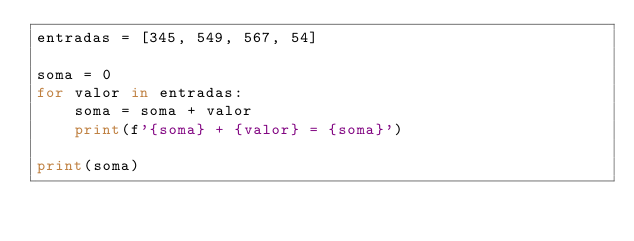<code> <loc_0><loc_0><loc_500><loc_500><_Python_>entradas = [345, 549, 567, 54]

soma = 0
for valor in entradas:
    soma = soma + valor
    print(f'{soma} + {valor} = {soma}')
    
print(soma)
</code> 